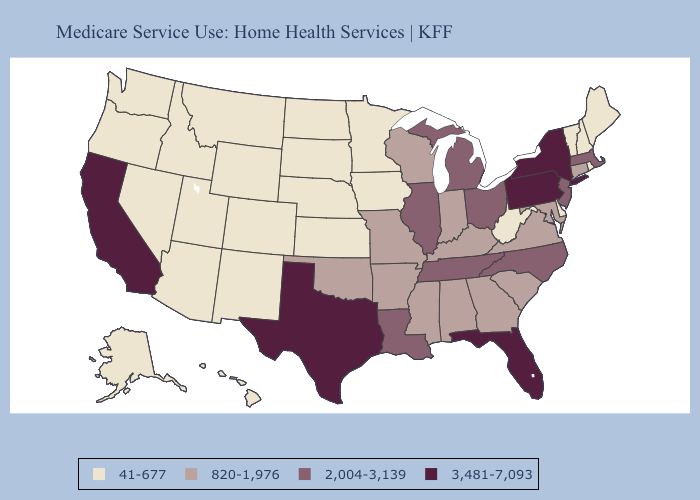Name the states that have a value in the range 2,004-3,139?
Quick response, please. Illinois, Louisiana, Massachusetts, Michigan, New Jersey, North Carolina, Ohio, Tennessee. Does Mississippi have the highest value in the USA?
Short answer required. No. What is the highest value in states that border Michigan?
Answer briefly. 2,004-3,139. Does South Carolina have a higher value than Washington?
Quick response, please. Yes. Does the map have missing data?
Concise answer only. No. Which states have the lowest value in the South?
Answer briefly. Delaware, West Virginia. Among the states that border Massachusetts , which have the highest value?
Quick response, please. New York. Which states have the lowest value in the USA?
Write a very short answer. Alaska, Arizona, Colorado, Delaware, Hawaii, Idaho, Iowa, Kansas, Maine, Minnesota, Montana, Nebraska, Nevada, New Hampshire, New Mexico, North Dakota, Oregon, Rhode Island, South Dakota, Utah, Vermont, Washington, West Virginia, Wyoming. What is the value of Mississippi?
Give a very brief answer. 820-1,976. Does Oregon have a lower value than Wisconsin?
Answer briefly. Yes. What is the value of Mississippi?
Answer briefly. 820-1,976. Name the states that have a value in the range 41-677?
Quick response, please. Alaska, Arizona, Colorado, Delaware, Hawaii, Idaho, Iowa, Kansas, Maine, Minnesota, Montana, Nebraska, Nevada, New Hampshire, New Mexico, North Dakota, Oregon, Rhode Island, South Dakota, Utah, Vermont, Washington, West Virginia, Wyoming. Does Washington have the lowest value in the USA?
Write a very short answer. Yes. 